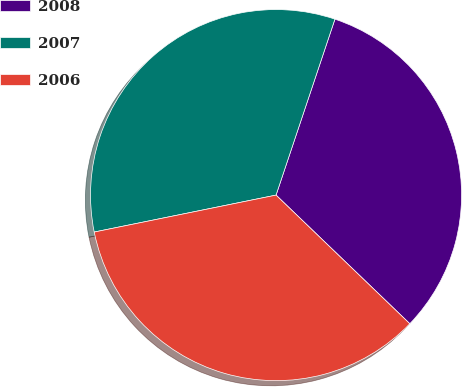Convert chart. <chart><loc_0><loc_0><loc_500><loc_500><pie_chart><fcel>2008<fcel>2007<fcel>2006<nl><fcel>32.05%<fcel>33.33%<fcel>34.62%<nl></chart> 